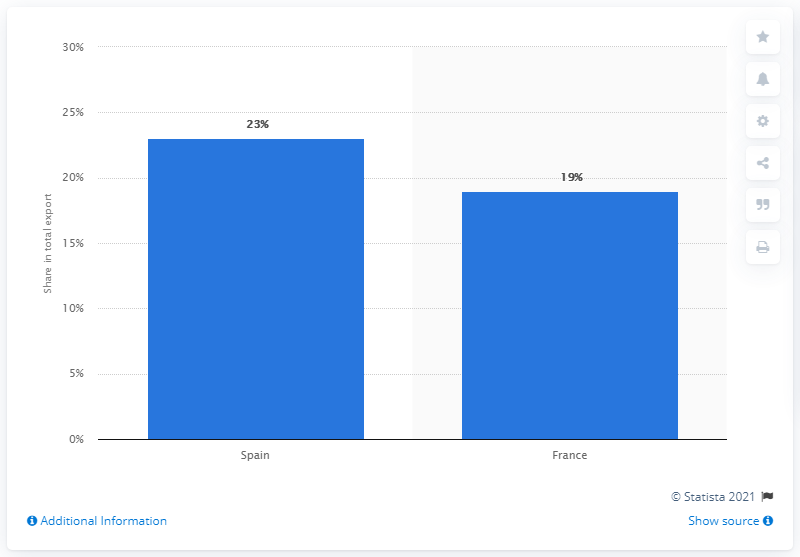Mention a couple of crucial points in this snapshot. In 2019, Spain accounted for approximately 23% of Morocco's total exports. According to the data from 2019, Spain was Morocco's most significant export partner. 